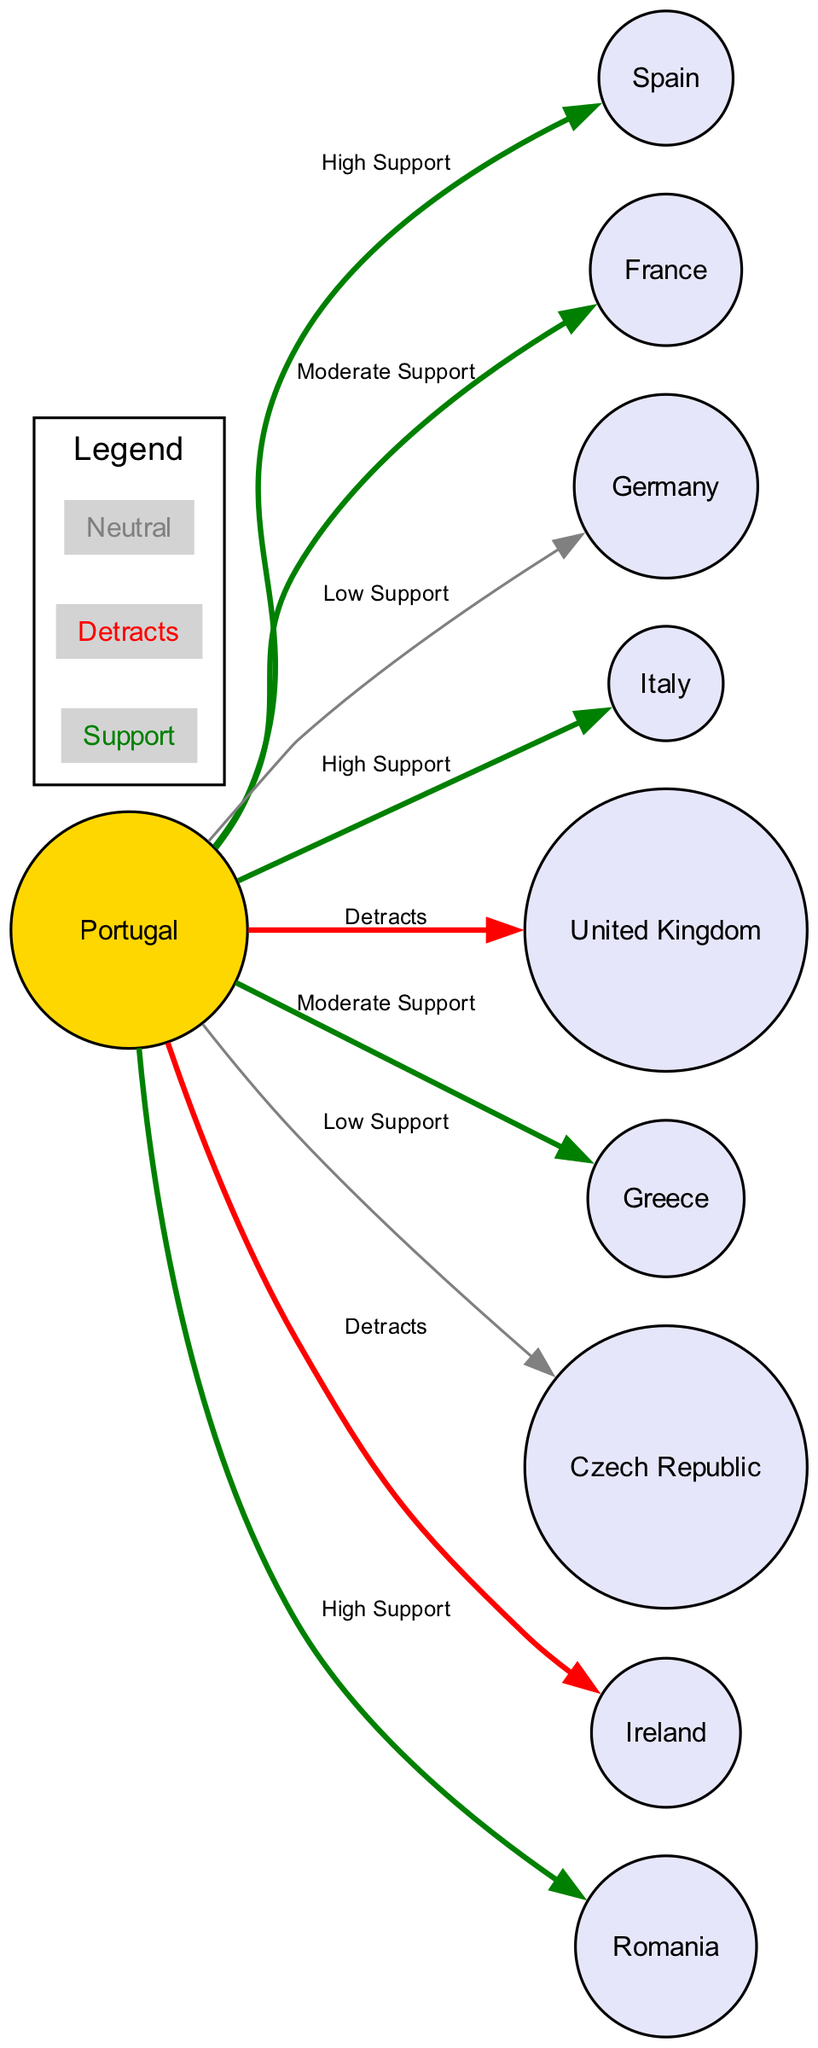What country has the highest support for Portugal? The diagram indicates that Romania provides "High Support" to Portugal. To find this, I look at the edges connected to Portugal and identify the edge with the label "High Support." The connection to Romania fits this criterion.
Answer: Romania Which country is labeled as detracting from Portugal? Two edges in the diagram indicate a negative relationship with Portugal: one to the United Kingdom and one to Ireland. Focusing on the labels, both are categorized as "Detracts," showcasing their negative impact on Portugal's score.
Answer: United Kingdom, Ireland How many countries provide moderate support to Portugal? The diagram shows three edges labeled as "Moderate Support." Checking the edges connected to Portugal, the connections to France and Greece are marked as "Moderate Support." Therefore, the answer is based on counting these relationships.
Answer: 2 List the countries that have low support for Portugal. The edge connections to Portugal show two countries listed under "Low Support," which are Germany and the Czech Republic. By carefully checking each edge, I identify these two connections to be categorized as low support.
Answer: Germany, Czech Republic Which country has the least positive interaction with Portugal? The edges depict relationships with positive, neutral, and negative labels. Among the edges marked positively, Germany and the Czech Republic show as "Low Support." Interpreting the lowest positive interaction uniquely refers to Germany, since it has only one edge marked positively.
Answer: Germany How many total countries interact with Portugal in the diagram? The diagram includes a total of ten countries connected to Portugal, including Portugal itself. Counting all the nodes and edges extending from Portugal provides the total of interacting countries.
Answer: 10 What is the color representing countries that detract from Portugal? In the diagram, the countries that detract from Portugal are represented using the color red, according to the color key. This is directly indicated in the legend section showing the differentiation between support, neutrality, and detracting countries.
Answer: Red Which country showing support is closest to Portugal geographically according to the diagram? The diagram showcases the relationship with Spain as having "High Support," which is also its closest geographical neighbor. Assessing the proximity and positive interaction leads to identifying Spain as the right answer.
Answer: Spain 